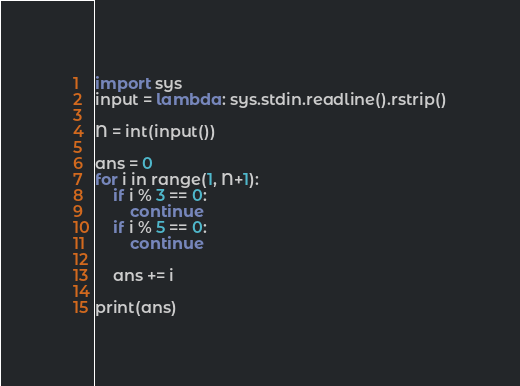<code> <loc_0><loc_0><loc_500><loc_500><_Python_>import sys
input = lambda: sys.stdin.readline().rstrip()

N = int(input())

ans = 0
for i in range(1, N+1):
    if i % 3 == 0:
        continue
    if i % 5 == 0:
        continue
    
    ans += i

print(ans)</code> 